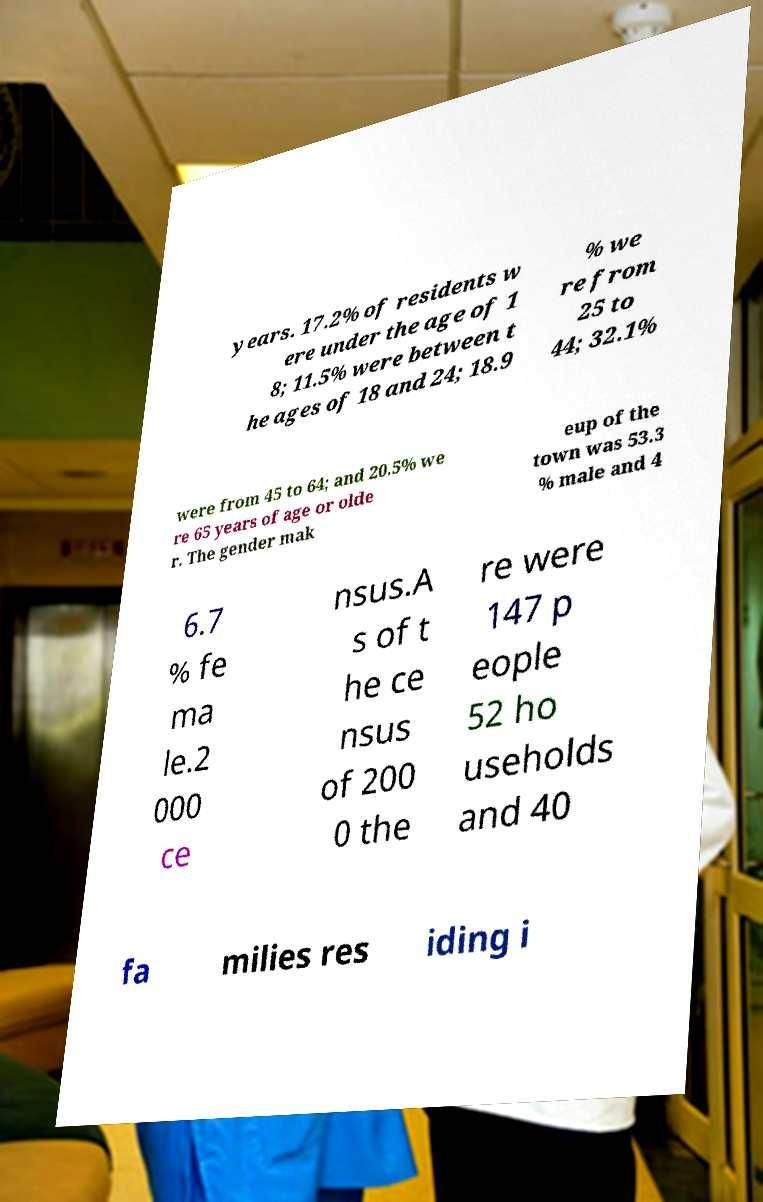Please identify and transcribe the text found in this image. years. 17.2% of residents w ere under the age of 1 8; 11.5% were between t he ages of 18 and 24; 18.9 % we re from 25 to 44; 32.1% were from 45 to 64; and 20.5% we re 65 years of age or olde r. The gender mak eup of the town was 53.3 % male and 4 6.7 % fe ma le.2 000 ce nsus.A s of t he ce nsus of 200 0 the re were 147 p eople 52 ho useholds and 40 fa milies res iding i 